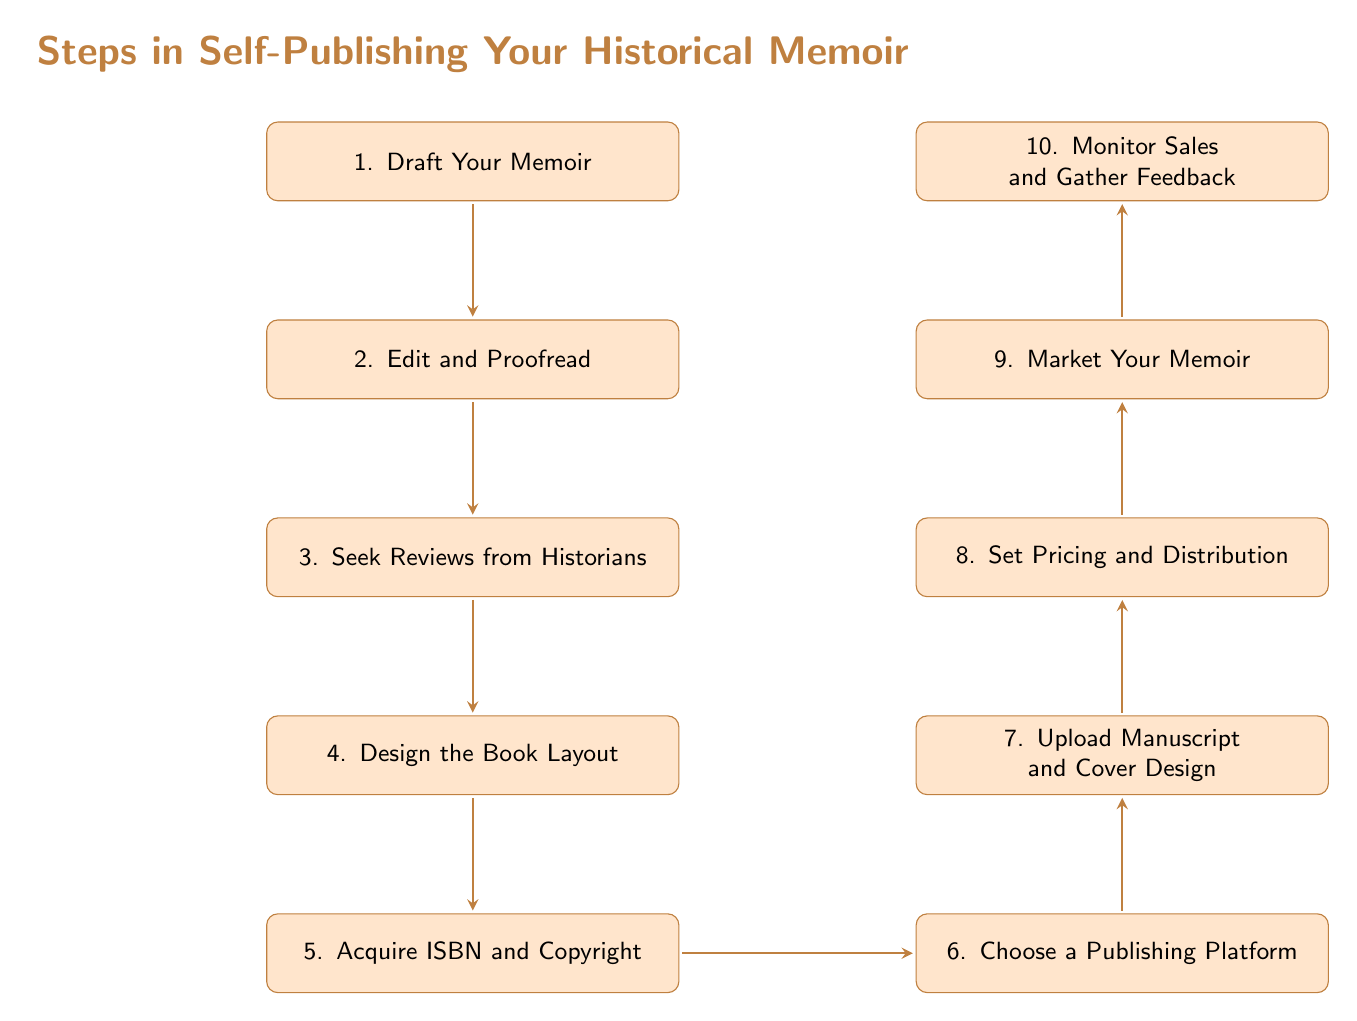what is the first step in the flow chart? The flow chart starts with the first box labeled "1. Draft Your Memoir," indicating it is the initial step in the self-publishing process.
Answer: Draft Your Memoir how many total steps are there in the diagram? By counting the nodes in the diagram, I can see there are ten distinct steps listed from 1 to 10, representing the entire process of self-publishing.
Answer: 10 which step comes after "Edit and Proofread"? Following the box labeled "2. Edit and Proofread," the next step in the sequence is "3. Seek Reviews from Historians," as indicated by the directional arrow connecting these two steps.
Answer: Seek Reviews from Historians what is the last step in the self-publishing process? The last box at the bottom of the flow chart is labeled "10. Monitor Sales and Gather Feedback," making it the final step in the process.
Answer: Monitor Sales and Gather Feedback which step involves acquiring ISBN and copyright? The fifth step in the flow chart is specifically labeled "5. Acquire ISBN and Copyright," directly indicating the actions related to acquiring these legal protections.
Answer: Acquire ISBN and Copyright what steps are dedicated to marketing the memoir? The ninth step is labeled "9. Market Your Memoir," which outlines the marketing actions necessary to promote the memoir, including leveraging social media and local history groups.
Answer: Market Your Memoir is the "Design the Book Layout" step before or after "Seek Reviews from Historians"? In the order of steps in the flow chart, "4. Design the Book Layout" occurs after "3. Seek Reviews from Historians," reflecting the sequence of the publishing process.
Answer: After what must be done before uploading the manuscript? According to the flow, "5. Acquire ISBN and Copyright" must be completed before moving to "7. Upload Manuscript and Cover Design," indicating a necessary legal step before the upload.
Answer: Acquire ISBN and Copyright which two steps are directly connected to "Choose a Publishing Platform"? The flow shows that "5. Acquire ISBN and Copyright" leads directly to "6. Choose a Publishing Platform," and then "6. Choose a Publishing Platform" leads to "7. Upload Manuscript and Cover Design." Therefore, these two steps are connected to it.
Answer: Acquire ISBN and Copyright, Upload Manuscript and Cover Design 